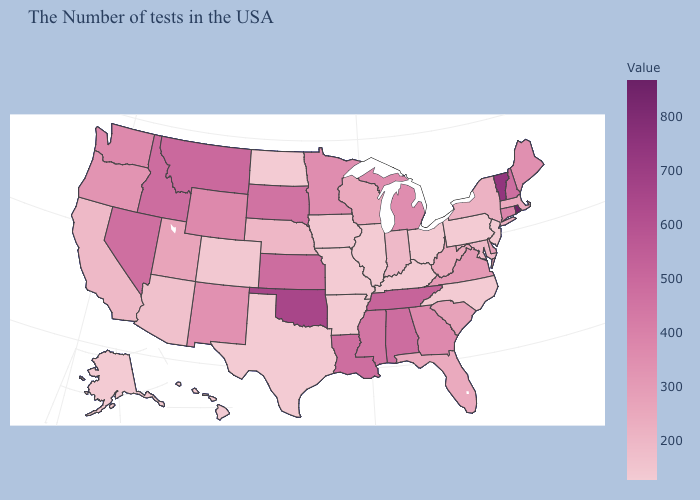Does West Virginia have a higher value than Rhode Island?
Be succinct. No. Does Nebraska have the highest value in the USA?
Be succinct. No. Does Ohio have a higher value than Georgia?
Give a very brief answer. No. Does Alabama have a higher value than Oklahoma?
Write a very short answer. No. Does Alaska have the lowest value in the USA?
Concise answer only. Yes. 